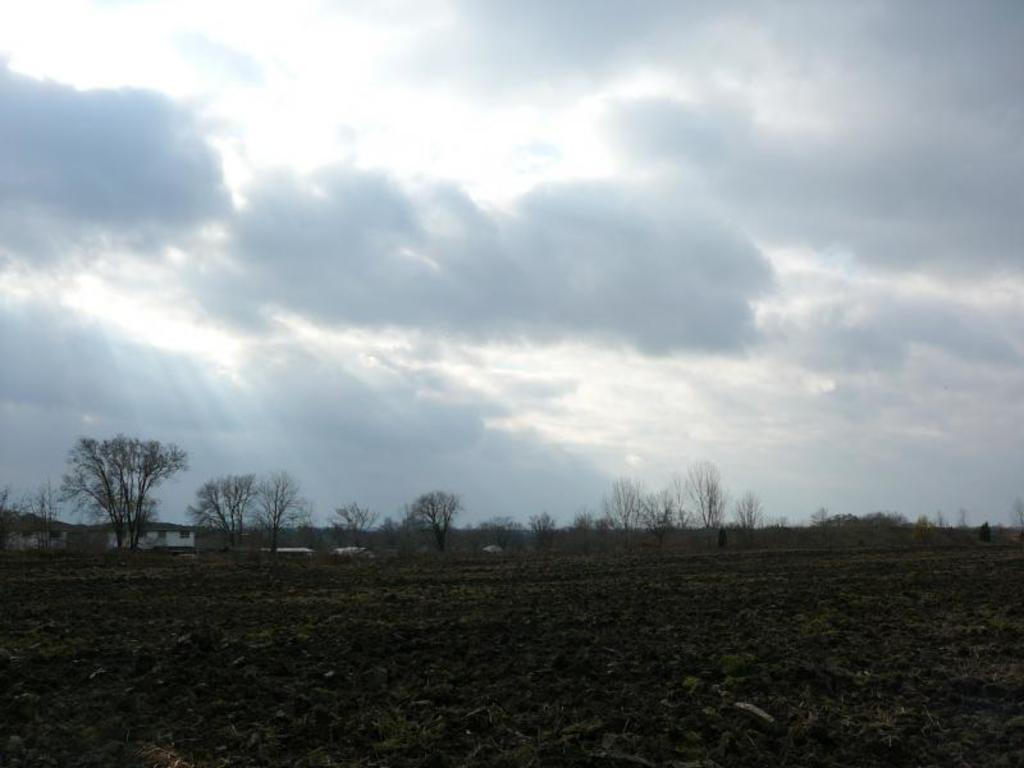What type of landscape is depicted in the image? The image consists of a land. What can be seen at the bottom of the image? There is ground at the bottom of the image. What type of vegetation is present in the image? There are trees in the front of the image. What is visible in the sky at the top of the image? There are clouds in the sky at the top of the image. What is the governor doing in the image? There is no governor present in the image. What type of string can be seen connecting the trees in the image? There is no string connecting the trees in the image. 